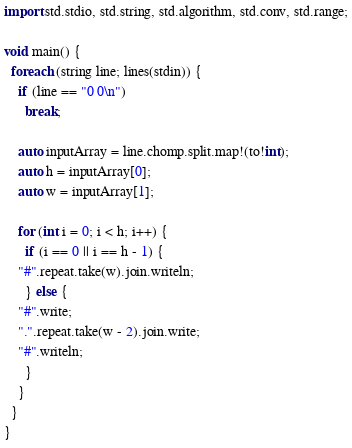<code> <loc_0><loc_0><loc_500><loc_500><_D_>import std.stdio, std.string, std.algorithm, std.conv, std.range;

void main() {
  foreach (string line; lines(stdin)) {
    if (line == "0 0\n")
      break;

    auto inputArray = line.chomp.split.map!(to!int);
    auto h = inputArray[0];
    auto w = inputArray[1];

    for (int i = 0; i < h; i++) {
      if (i == 0 || i == h - 1) {
	"#".repeat.take(w).join.writeln;
      } else {
	"#".write;
	".".repeat.take(w - 2).join.write;
	"#".writeln;
      }
    }
  }
}</code> 